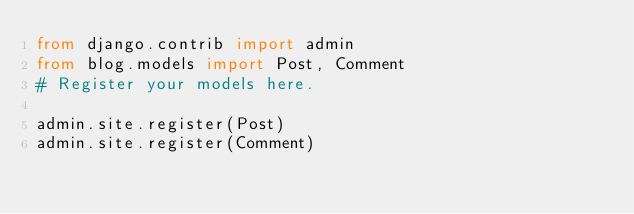Convert code to text. <code><loc_0><loc_0><loc_500><loc_500><_Python_>from django.contrib import admin
from blog.models import Post, Comment
# Register your models here.

admin.site.register(Post)
admin.site.register(Comment)
</code> 